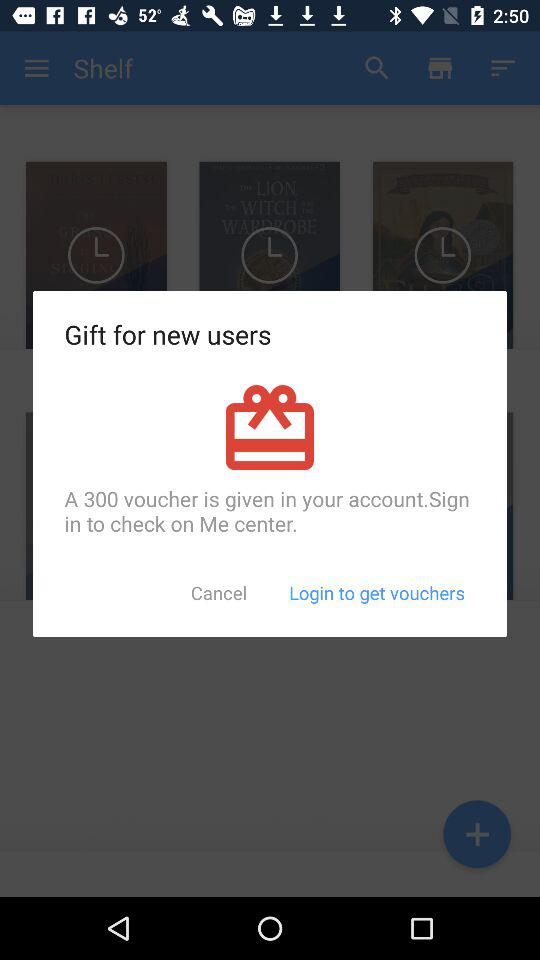How many vouchers are given to new users?
Answer the question using a single word or phrase. 300 